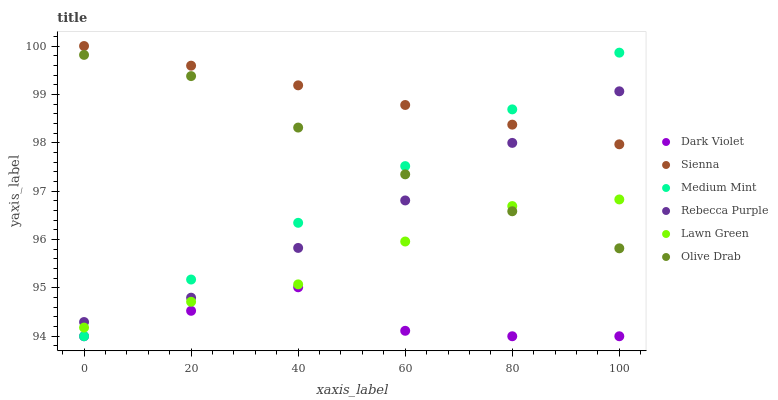Does Dark Violet have the minimum area under the curve?
Answer yes or no. Yes. Does Sienna have the maximum area under the curve?
Answer yes or no. Yes. Does Lawn Green have the minimum area under the curve?
Answer yes or no. No. Does Lawn Green have the maximum area under the curve?
Answer yes or no. No. Is Sienna the smoothest?
Answer yes or no. Yes. Is Dark Violet the roughest?
Answer yes or no. Yes. Is Lawn Green the smoothest?
Answer yes or no. No. Is Lawn Green the roughest?
Answer yes or no. No. Does Medium Mint have the lowest value?
Answer yes or no. Yes. Does Lawn Green have the lowest value?
Answer yes or no. No. Does Sienna have the highest value?
Answer yes or no. Yes. Does Lawn Green have the highest value?
Answer yes or no. No. Is Dark Violet less than Lawn Green?
Answer yes or no. Yes. Is Olive Drab greater than Dark Violet?
Answer yes or no. Yes. Does Dark Violet intersect Medium Mint?
Answer yes or no. Yes. Is Dark Violet less than Medium Mint?
Answer yes or no. No. Is Dark Violet greater than Medium Mint?
Answer yes or no. No. Does Dark Violet intersect Lawn Green?
Answer yes or no. No. 